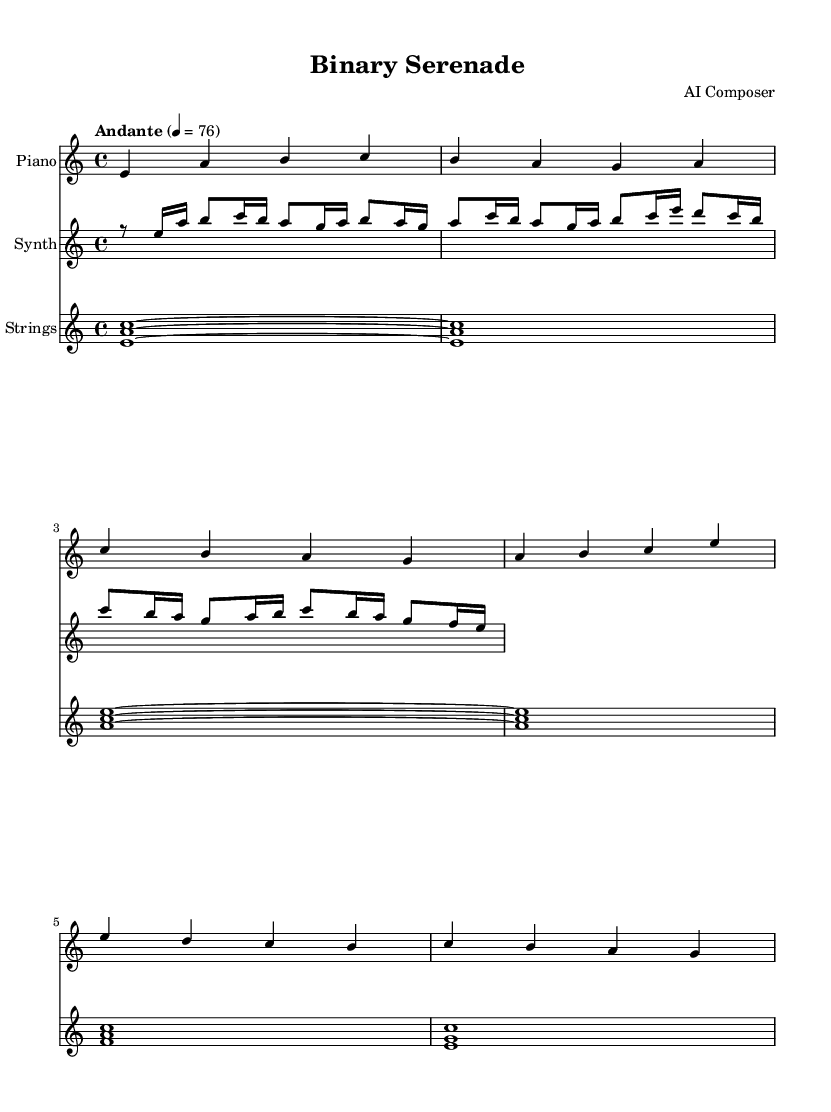What is the key signature of this music? The key signature is indicated at the beginning of the piece and shows that there are no sharps or flats. It corresponds to A minor, as it has no sharps or flats associated with the key signature.
Answer: A minor What is the time signature of this music? The time signature is located near the beginning of the sheet music, indicating the number of beats per measure. In this case, it is shown as 4/4, meaning there are four beats in each measure.
Answer: 4/4 What is the tempo marking for this composition? The tempo is specified at the beginning of the score, indicating the speed of the piece. It is written as "Andante" which translates to a moderately slow tempo, with a specific beat marking of 76.
Answer: Andante 76 How many measures are in the introduction section? The introduction section consists of the first two lines of the sheet music. Counting the measures presents a total of 4 measures in the introduction.
Answer: 4 Which instrument plays the opening melody? The opening melody is found in the first staff of the score and is primarily played by the piano. It starts off with a distinctive melodic line in the introduction.
Answer: Piano What types of harmony are used in the strings part? The strings part in this composition primarily features triadic harmony, as indicated by the simultaneous notes being played in chords (e.g., <e a c>). This creates a rich harmonic texture.
Answer: Triadic harmony How does the synthesizer part contribute to the emotional tone of the composition? The synthesizer part incorporates both rhythmic and melodic elements, with rapid note changes and harmony that enhance the overall dreamy and romantic quality of the piece. This interaction between synthetic sound and classical structure enhances the emotional impact significantly.
Answer: Emotional enhancement 